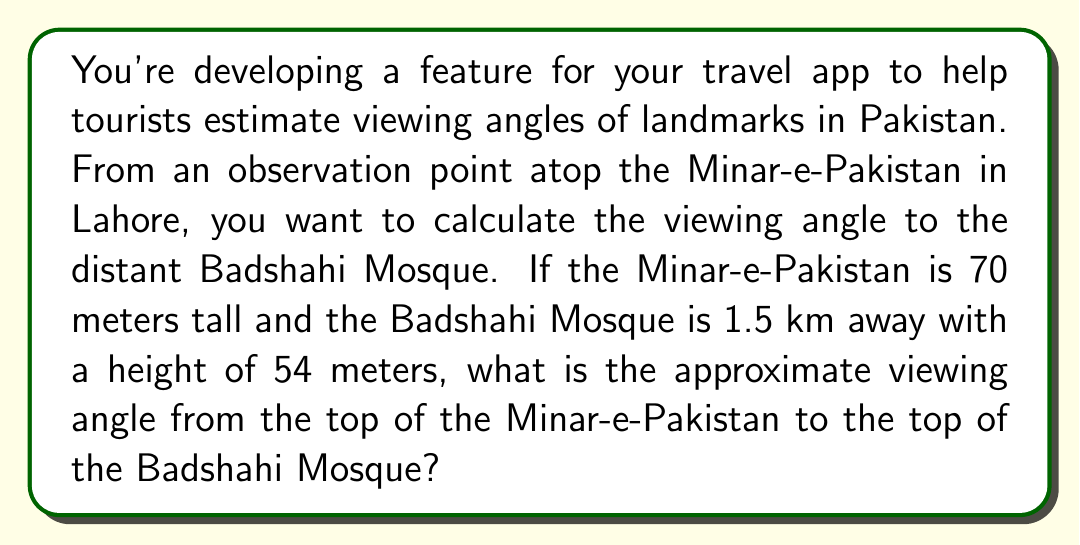Provide a solution to this math problem. To solve this problem, we'll use trigonometry. Let's break it down step-by-step:

1. Visualize the problem:
   [asy]
   import geometry;
   
   pair A = (0,0);
   pair B = (15,0);
   pair C = (0,0.7);
   pair D = (15,0.54);
   
   draw(A--B--D--C--cycle);
   draw(C--D,dashed);
   
   label("Ground", (7.5,-0.1), S);
   label("1.5 km", (7.5,-0.2), S);
   label("70 m", (-0.2,0.35), W);
   label("54 m", (15.2,0.27), E);
   label("θ", (0.2,0.7), NW);
   label("Minar-e-Pakistan", (0,0), SW);
   label("Badshahi Mosque", (15,0), SE);
   
   dot(A); dot(B); dot(C); dot(D);
   ]

2. We need to find the angle θ at the top of Minar-e-Pakistan.

3. Calculate the height difference:
   $\text{Height difference} = 70\text{ m} - 54\text{ m} = 16\text{ m}$

4. We now have a right triangle with:
   - Adjacent side (horizontal distance) = 1.5 km = 1500 m
   - Opposite side (height difference) = 16 m

5. Use the arctangent function to find the angle:
   $$θ = \tan^{-1}\left(\frac{\text{opposite}}{\text{adjacent}}\right) = \tan^{-1}\left(\frac{16}{1500}\right)$$

6. Calculate:
   $$θ = \tan^{-1}\left(\frac{16}{1500}\right) \approx 0.6107 \text{ degrees}$$

7. Round to two decimal places:
   $$θ \approx 0.61 \text{ degrees}$$
Answer: 0.61° 